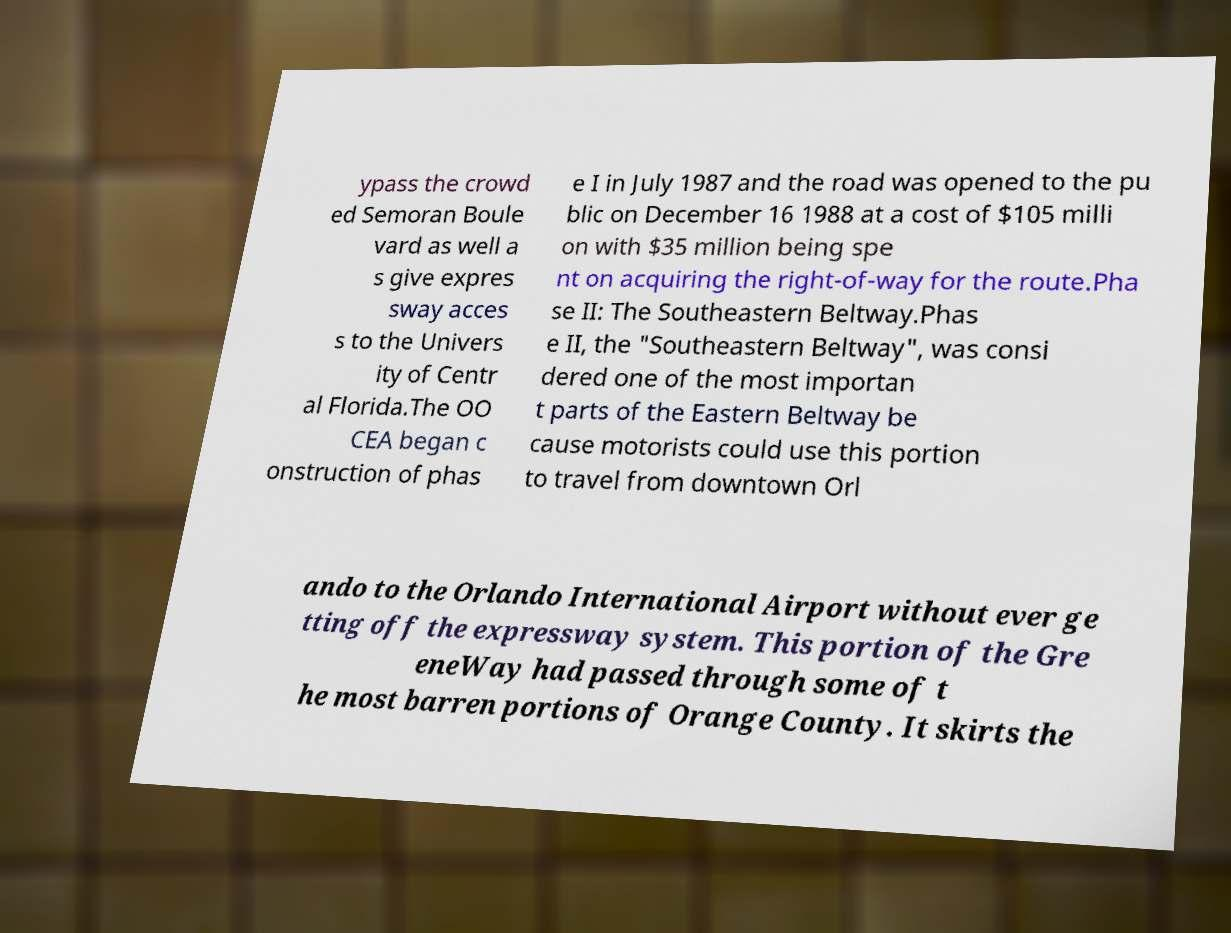Can you read and provide the text displayed in the image?This photo seems to have some interesting text. Can you extract and type it out for me? ypass the crowd ed Semoran Boule vard as well a s give expres sway acces s to the Univers ity of Centr al Florida.The OO CEA began c onstruction of phas e I in July 1987 and the road was opened to the pu blic on December 16 1988 at a cost of $105 milli on with $35 million being spe nt on acquiring the right-of-way for the route.Pha se II: The Southeastern Beltway.Phas e II, the "Southeastern Beltway", was consi dered one of the most importan t parts of the Eastern Beltway be cause motorists could use this portion to travel from downtown Orl ando to the Orlando International Airport without ever ge tting off the expressway system. This portion of the Gre eneWay had passed through some of t he most barren portions of Orange County. It skirts the 